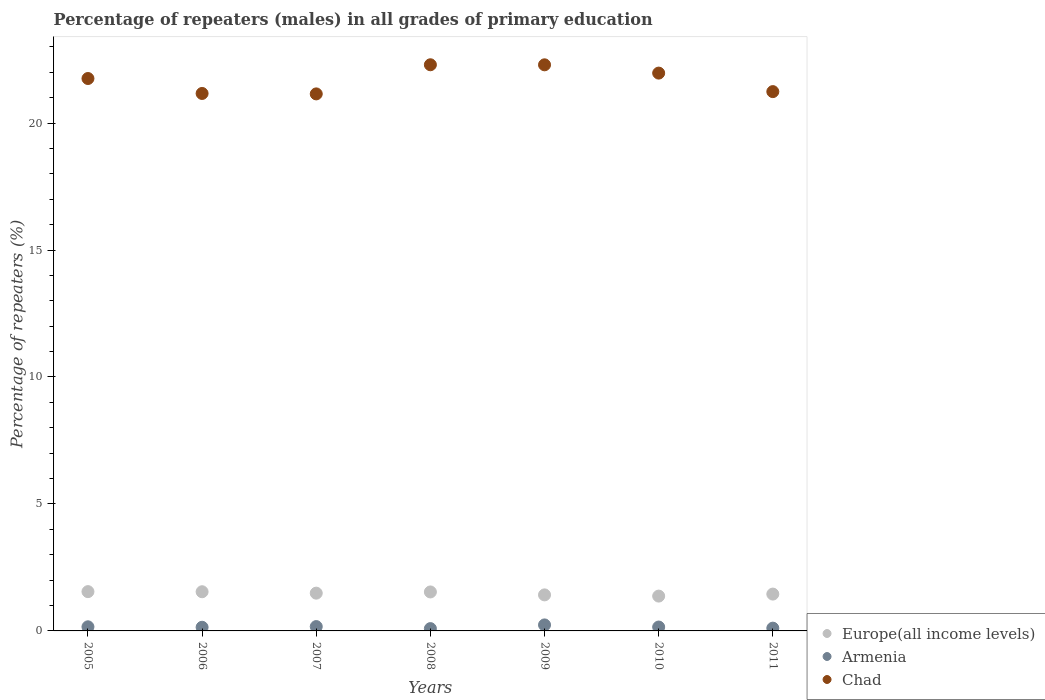Is the number of dotlines equal to the number of legend labels?
Your answer should be very brief. Yes. What is the percentage of repeaters (males) in Chad in 2008?
Keep it short and to the point. 22.29. Across all years, what is the maximum percentage of repeaters (males) in Europe(all income levels)?
Ensure brevity in your answer.  1.55. Across all years, what is the minimum percentage of repeaters (males) in Chad?
Give a very brief answer. 21.15. In which year was the percentage of repeaters (males) in Chad maximum?
Keep it short and to the point. 2008. In which year was the percentage of repeaters (males) in Chad minimum?
Your response must be concise. 2007. What is the total percentage of repeaters (males) in Europe(all income levels) in the graph?
Your answer should be very brief. 10.35. What is the difference between the percentage of repeaters (males) in Europe(all income levels) in 2005 and that in 2006?
Give a very brief answer. 0. What is the difference between the percentage of repeaters (males) in Europe(all income levels) in 2006 and the percentage of repeaters (males) in Chad in 2008?
Make the answer very short. -20.75. What is the average percentage of repeaters (males) in Europe(all income levels) per year?
Your answer should be very brief. 1.48. In the year 2007, what is the difference between the percentage of repeaters (males) in Chad and percentage of repeaters (males) in Armenia?
Your answer should be compact. 20.98. What is the ratio of the percentage of repeaters (males) in Armenia in 2006 to that in 2008?
Provide a short and direct response. 1.58. Is the difference between the percentage of repeaters (males) in Chad in 2007 and 2010 greater than the difference between the percentage of repeaters (males) in Armenia in 2007 and 2010?
Your response must be concise. No. What is the difference between the highest and the second highest percentage of repeaters (males) in Chad?
Offer a terse response. 0. What is the difference between the highest and the lowest percentage of repeaters (males) in Armenia?
Your answer should be compact. 0.15. In how many years, is the percentage of repeaters (males) in Armenia greater than the average percentage of repeaters (males) in Armenia taken over all years?
Offer a terse response. 4. Is the sum of the percentage of repeaters (males) in Armenia in 2005 and 2009 greater than the maximum percentage of repeaters (males) in Chad across all years?
Your answer should be compact. No. How many dotlines are there?
Offer a very short reply. 3. How many years are there in the graph?
Offer a terse response. 7. What is the difference between two consecutive major ticks on the Y-axis?
Ensure brevity in your answer.  5. Where does the legend appear in the graph?
Make the answer very short. Bottom right. What is the title of the graph?
Your answer should be compact. Percentage of repeaters (males) in all grades of primary education. Does "Switzerland" appear as one of the legend labels in the graph?
Keep it short and to the point. No. What is the label or title of the X-axis?
Give a very brief answer. Years. What is the label or title of the Y-axis?
Give a very brief answer. Percentage of repeaters (%). What is the Percentage of repeaters (%) in Europe(all income levels) in 2005?
Provide a succinct answer. 1.55. What is the Percentage of repeaters (%) of Armenia in 2005?
Keep it short and to the point. 0.16. What is the Percentage of repeaters (%) in Chad in 2005?
Your response must be concise. 21.75. What is the Percentage of repeaters (%) of Europe(all income levels) in 2006?
Offer a very short reply. 1.54. What is the Percentage of repeaters (%) of Armenia in 2006?
Provide a short and direct response. 0.14. What is the Percentage of repeaters (%) in Chad in 2006?
Make the answer very short. 21.16. What is the Percentage of repeaters (%) of Europe(all income levels) in 2007?
Your answer should be very brief. 1.49. What is the Percentage of repeaters (%) in Armenia in 2007?
Give a very brief answer. 0.17. What is the Percentage of repeaters (%) in Chad in 2007?
Keep it short and to the point. 21.15. What is the Percentage of repeaters (%) in Europe(all income levels) in 2008?
Keep it short and to the point. 1.53. What is the Percentage of repeaters (%) of Armenia in 2008?
Provide a short and direct response. 0.09. What is the Percentage of repeaters (%) in Chad in 2008?
Ensure brevity in your answer.  22.29. What is the Percentage of repeaters (%) in Europe(all income levels) in 2009?
Provide a succinct answer. 1.42. What is the Percentage of repeaters (%) of Armenia in 2009?
Your response must be concise. 0.24. What is the Percentage of repeaters (%) of Chad in 2009?
Give a very brief answer. 22.29. What is the Percentage of repeaters (%) of Europe(all income levels) in 2010?
Offer a very short reply. 1.37. What is the Percentage of repeaters (%) in Armenia in 2010?
Provide a short and direct response. 0.15. What is the Percentage of repeaters (%) in Chad in 2010?
Give a very brief answer. 21.97. What is the Percentage of repeaters (%) in Europe(all income levels) in 2011?
Ensure brevity in your answer.  1.45. What is the Percentage of repeaters (%) in Armenia in 2011?
Ensure brevity in your answer.  0.11. What is the Percentage of repeaters (%) of Chad in 2011?
Make the answer very short. 21.24. Across all years, what is the maximum Percentage of repeaters (%) in Europe(all income levels)?
Your response must be concise. 1.55. Across all years, what is the maximum Percentage of repeaters (%) of Armenia?
Your response must be concise. 0.24. Across all years, what is the maximum Percentage of repeaters (%) in Chad?
Make the answer very short. 22.29. Across all years, what is the minimum Percentage of repeaters (%) in Europe(all income levels)?
Your response must be concise. 1.37. Across all years, what is the minimum Percentage of repeaters (%) of Armenia?
Keep it short and to the point. 0.09. Across all years, what is the minimum Percentage of repeaters (%) of Chad?
Your answer should be compact. 21.15. What is the total Percentage of repeaters (%) of Europe(all income levels) in the graph?
Offer a very short reply. 10.35. What is the total Percentage of repeaters (%) in Armenia in the graph?
Ensure brevity in your answer.  1.07. What is the total Percentage of repeaters (%) in Chad in the graph?
Ensure brevity in your answer.  151.86. What is the difference between the Percentage of repeaters (%) of Europe(all income levels) in 2005 and that in 2006?
Your answer should be very brief. 0. What is the difference between the Percentage of repeaters (%) of Armenia in 2005 and that in 2006?
Give a very brief answer. 0.02. What is the difference between the Percentage of repeaters (%) in Chad in 2005 and that in 2006?
Offer a terse response. 0.59. What is the difference between the Percentage of repeaters (%) of Europe(all income levels) in 2005 and that in 2007?
Make the answer very short. 0.06. What is the difference between the Percentage of repeaters (%) of Armenia in 2005 and that in 2007?
Provide a succinct answer. -0.01. What is the difference between the Percentage of repeaters (%) of Chad in 2005 and that in 2007?
Provide a short and direct response. 0.61. What is the difference between the Percentage of repeaters (%) in Europe(all income levels) in 2005 and that in 2008?
Make the answer very short. 0.01. What is the difference between the Percentage of repeaters (%) in Armenia in 2005 and that in 2008?
Your answer should be compact. 0.07. What is the difference between the Percentage of repeaters (%) of Chad in 2005 and that in 2008?
Your response must be concise. -0.54. What is the difference between the Percentage of repeaters (%) in Europe(all income levels) in 2005 and that in 2009?
Provide a short and direct response. 0.13. What is the difference between the Percentage of repeaters (%) in Armenia in 2005 and that in 2009?
Offer a terse response. -0.07. What is the difference between the Percentage of repeaters (%) in Chad in 2005 and that in 2009?
Keep it short and to the point. -0.54. What is the difference between the Percentage of repeaters (%) of Europe(all income levels) in 2005 and that in 2010?
Your response must be concise. 0.18. What is the difference between the Percentage of repeaters (%) of Armenia in 2005 and that in 2010?
Make the answer very short. 0.01. What is the difference between the Percentage of repeaters (%) of Chad in 2005 and that in 2010?
Ensure brevity in your answer.  -0.21. What is the difference between the Percentage of repeaters (%) in Europe(all income levels) in 2005 and that in 2011?
Your answer should be very brief. 0.1. What is the difference between the Percentage of repeaters (%) in Armenia in 2005 and that in 2011?
Make the answer very short. 0.05. What is the difference between the Percentage of repeaters (%) in Chad in 2005 and that in 2011?
Your answer should be compact. 0.52. What is the difference between the Percentage of repeaters (%) in Europe(all income levels) in 2006 and that in 2007?
Offer a terse response. 0.06. What is the difference between the Percentage of repeaters (%) of Armenia in 2006 and that in 2007?
Provide a short and direct response. -0.03. What is the difference between the Percentage of repeaters (%) of Chad in 2006 and that in 2007?
Offer a very short reply. 0.02. What is the difference between the Percentage of repeaters (%) in Europe(all income levels) in 2006 and that in 2008?
Provide a short and direct response. 0.01. What is the difference between the Percentage of repeaters (%) of Armenia in 2006 and that in 2008?
Offer a terse response. 0.05. What is the difference between the Percentage of repeaters (%) of Chad in 2006 and that in 2008?
Make the answer very short. -1.13. What is the difference between the Percentage of repeaters (%) of Europe(all income levels) in 2006 and that in 2009?
Give a very brief answer. 0.12. What is the difference between the Percentage of repeaters (%) of Armenia in 2006 and that in 2009?
Your answer should be compact. -0.09. What is the difference between the Percentage of repeaters (%) in Chad in 2006 and that in 2009?
Your response must be concise. -1.13. What is the difference between the Percentage of repeaters (%) of Europe(all income levels) in 2006 and that in 2010?
Give a very brief answer. 0.17. What is the difference between the Percentage of repeaters (%) of Armenia in 2006 and that in 2010?
Offer a terse response. -0.01. What is the difference between the Percentage of repeaters (%) of Chad in 2006 and that in 2010?
Offer a very short reply. -0.8. What is the difference between the Percentage of repeaters (%) of Europe(all income levels) in 2006 and that in 2011?
Your answer should be compact. 0.09. What is the difference between the Percentage of repeaters (%) of Armenia in 2006 and that in 2011?
Give a very brief answer. 0.03. What is the difference between the Percentage of repeaters (%) in Chad in 2006 and that in 2011?
Provide a succinct answer. -0.07. What is the difference between the Percentage of repeaters (%) in Europe(all income levels) in 2007 and that in 2008?
Offer a terse response. -0.05. What is the difference between the Percentage of repeaters (%) of Armenia in 2007 and that in 2008?
Your answer should be very brief. 0.08. What is the difference between the Percentage of repeaters (%) in Chad in 2007 and that in 2008?
Your answer should be very brief. -1.15. What is the difference between the Percentage of repeaters (%) in Europe(all income levels) in 2007 and that in 2009?
Provide a succinct answer. 0.07. What is the difference between the Percentage of repeaters (%) of Armenia in 2007 and that in 2009?
Your response must be concise. -0.07. What is the difference between the Percentage of repeaters (%) in Chad in 2007 and that in 2009?
Offer a very short reply. -1.15. What is the difference between the Percentage of repeaters (%) of Europe(all income levels) in 2007 and that in 2010?
Your answer should be very brief. 0.12. What is the difference between the Percentage of repeaters (%) of Armenia in 2007 and that in 2010?
Offer a terse response. 0.02. What is the difference between the Percentage of repeaters (%) of Chad in 2007 and that in 2010?
Provide a succinct answer. -0.82. What is the difference between the Percentage of repeaters (%) of Europe(all income levels) in 2007 and that in 2011?
Make the answer very short. 0.04. What is the difference between the Percentage of repeaters (%) in Armenia in 2007 and that in 2011?
Your answer should be compact. 0.06. What is the difference between the Percentage of repeaters (%) in Chad in 2007 and that in 2011?
Your response must be concise. -0.09. What is the difference between the Percentage of repeaters (%) in Europe(all income levels) in 2008 and that in 2009?
Make the answer very short. 0.12. What is the difference between the Percentage of repeaters (%) of Armenia in 2008 and that in 2009?
Your response must be concise. -0.15. What is the difference between the Percentage of repeaters (%) of Chad in 2008 and that in 2009?
Give a very brief answer. 0. What is the difference between the Percentage of repeaters (%) in Europe(all income levels) in 2008 and that in 2010?
Keep it short and to the point. 0.16. What is the difference between the Percentage of repeaters (%) of Armenia in 2008 and that in 2010?
Give a very brief answer. -0.06. What is the difference between the Percentage of repeaters (%) in Chad in 2008 and that in 2010?
Keep it short and to the point. 0.33. What is the difference between the Percentage of repeaters (%) of Europe(all income levels) in 2008 and that in 2011?
Make the answer very short. 0.08. What is the difference between the Percentage of repeaters (%) in Armenia in 2008 and that in 2011?
Offer a terse response. -0.02. What is the difference between the Percentage of repeaters (%) of Chad in 2008 and that in 2011?
Your answer should be compact. 1.06. What is the difference between the Percentage of repeaters (%) of Europe(all income levels) in 2009 and that in 2010?
Provide a short and direct response. 0.05. What is the difference between the Percentage of repeaters (%) of Armenia in 2009 and that in 2010?
Your answer should be very brief. 0.08. What is the difference between the Percentage of repeaters (%) of Chad in 2009 and that in 2010?
Your response must be concise. 0.33. What is the difference between the Percentage of repeaters (%) of Europe(all income levels) in 2009 and that in 2011?
Make the answer very short. -0.03. What is the difference between the Percentage of repeaters (%) in Armenia in 2009 and that in 2011?
Provide a short and direct response. 0.13. What is the difference between the Percentage of repeaters (%) in Chad in 2009 and that in 2011?
Offer a very short reply. 1.06. What is the difference between the Percentage of repeaters (%) in Europe(all income levels) in 2010 and that in 2011?
Offer a very short reply. -0.08. What is the difference between the Percentage of repeaters (%) of Armenia in 2010 and that in 2011?
Give a very brief answer. 0.04. What is the difference between the Percentage of repeaters (%) of Chad in 2010 and that in 2011?
Make the answer very short. 0.73. What is the difference between the Percentage of repeaters (%) in Europe(all income levels) in 2005 and the Percentage of repeaters (%) in Armenia in 2006?
Provide a succinct answer. 1.4. What is the difference between the Percentage of repeaters (%) in Europe(all income levels) in 2005 and the Percentage of repeaters (%) in Chad in 2006?
Your answer should be compact. -19.62. What is the difference between the Percentage of repeaters (%) in Armenia in 2005 and the Percentage of repeaters (%) in Chad in 2006?
Provide a succinct answer. -21. What is the difference between the Percentage of repeaters (%) of Europe(all income levels) in 2005 and the Percentage of repeaters (%) of Armenia in 2007?
Your answer should be very brief. 1.38. What is the difference between the Percentage of repeaters (%) in Europe(all income levels) in 2005 and the Percentage of repeaters (%) in Chad in 2007?
Ensure brevity in your answer.  -19.6. What is the difference between the Percentage of repeaters (%) in Armenia in 2005 and the Percentage of repeaters (%) in Chad in 2007?
Your answer should be very brief. -20.99. What is the difference between the Percentage of repeaters (%) in Europe(all income levels) in 2005 and the Percentage of repeaters (%) in Armenia in 2008?
Offer a very short reply. 1.46. What is the difference between the Percentage of repeaters (%) in Europe(all income levels) in 2005 and the Percentage of repeaters (%) in Chad in 2008?
Your response must be concise. -20.75. What is the difference between the Percentage of repeaters (%) of Armenia in 2005 and the Percentage of repeaters (%) of Chad in 2008?
Give a very brief answer. -22.13. What is the difference between the Percentage of repeaters (%) of Europe(all income levels) in 2005 and the Percentage of repeaters (%) of Armenia in 2009?
Offer a terse response. 1.31. What is the difference between the Percentage of repeaters (%) of Europe(all income levels) in 2005 and the Percentage of repeaters (%) of Chad in 2009?
Provide a succinct answer. -20.75. What is the difference between the Percentage of repeaters (%) in Armenia in 2005 and the Percentage of repeaters (%) in Chad in 2009?
Your response must be concise. -22.13. What is the difference between the Percentage of repeaters (%) in Europe(all income levels) in 2005 and the Percentage of repeaters (%) in Armenia in 2010?
Your answer should be compact. 1.39. What is the difference between the Percentage of repeaters (%) of Europe(all income levels) in 2005 and the Percentage of repeaters (%) of Chad in 2010?
Offer a terse response. -20.42. What is the difference between the Percentage of repeaters (%) of Armenia in 2005 and the Percentage of repeaters (%) of Chad in 2010?
Make the answer very short. -21.8. What is the difference between the Percentage of repeaters (%) of Europe(all income levels) in 2005 and the Percentage of repeaters (%) of Armenia in 2011?
Ensure brevity in your answer.  1.44. What is the difference between the Percentage of repeaters (%) of Europe(all income levels) in 2005 and the Percentage of repeaters (%) of Chad in 2011?
Ensure brevity in your answer.  -19.69. What is the difference between the Percentage of repeaters (%) of Armenia in 2005 and the Percentage of repeaters (%) of Chad in 2011?
Offer a very short reply. -21.08. What is the difference between the Percentage of repeaters (%) in Europe(all income levels) in 2006 and the Percentage of repeaters (%) in Armenia in 2007?
Keep it short and to the point. 1.37. What is the difference between the Percentage of repeaters (%) of Europe(all income levels) in 2006 and the Percentage of repeaters (%) of Chad in 2007?
Keep it short and to the point. -19.6. What is the difference between the Percentage of repeaters (%) of Armenia in 2006 and the Percentage of repeaters (%) of Chad in 2007?
Ensure brevity in your answer.  -21. What is the difference between the Percentage of repeaters (%) in Europe(all income levels) in 2006 and the Percentage of repeaters (%) in Armenia in 2008?
Keep it short and to the point. 1.45. What is the difference between the Percentage of repeaters (%) in Europe(all income levels) in 2006 and the Percentage of repeaters (%) in Chad in 2008?
Ensure brevity in your answer.  -20.75. What is the difference between the Percentage of repeaters (%) in Armenia in 2006 and the Percentage of repeaters (%) in Chad in 2008?
Your answer should be compact. -22.15. What is the difference between the Percentage of repeaters (%) in Europe(all income levels) in 2006 and the Percentage of repeaters (%) in Armenia in 2009?
Your answer should be compact. 1.31. What is the difference between the Percentage of repeaters (%) of Europe(all income levels) in 2006 and the Percentage of repeaters (%) of Chad in 2009?
Give a very brief answer. -20.75. What is the difference between the Percentage of repeaters (%) in Armenia in 2006 and the Percentage of repeaters (%) in Chad in 2009?
Your answer should be compact. -22.15. What is the difference between the Percentage of repeaters (%) of Europe(all income levels) in 2006 and the Percentage of repeaters (%) of Armenia in 2010?
Your response must be concise. 1.39. What is the difference between the Percentage of repeaters (%) of Europe(all income levels) in 2006 and the Percentage of repeaters (%) of Chad in 2010?
Offer a very short reply. -20.42. What is the difference between the Percentage of repeaters (%) in Armenia in 2006 and the Percentage of repeaters (%) in Chad in 2010?
Ensure brevity in your answer.  -21.82. What is the difference between the Percentage of repeaters (%) in Europe(all income levels) in 2006 and the Percentage of repeaters (%) in Armenia in 2011?
Your answer should be compact. 1.43. What is the difference between the Percentage of repeaters (%) in Europe(all income levels) in 2006 and the Percentage of repeaters (%) in Chad in 2011?
Provide a succinct answer. -19.69. What is the difference between the Percentage of repeaters (%) in Armenia in 2006 and the Percentage of repeaters (%) in Chad in 2011?
Make the answer very short. -21.09. What is the difference between the Percentage of repeaters (%) in Europe(all income levels) in 2007 and the Percentage of repeaters (%) in Armenia in 2008?
Your response must be concise. 1.4. What is the difference between the Percentage of repeaters (%) of Europe(all income levels) in 2007 and the Percentage of repeaters (%) of Chad in 2008?
Your answer should be compact. -20.81. What is the difference between the Percentage of repeaters (%) of Armenia in 2007 and the Percentage of repeaters (%) of Chad in 2008?
Offer a very short reply. -22.12. What is the difference between the Percentage of repeaters (%) in Europe(all income levels) in 2007 and the Percentage of repeaters (%) in Armenia in 2009?
Your answer should be very brief. 1.25. What is the difference between the Percentage of repeaters (%) in Europe(all income levels) in 2007 and the Percentage of repeaters (%) in Chad in 2009?
Provide a short and direct response. -20.81. What is the difference between the Percentage of repeaters (%) in Armenia in 2007 and the Percentage of repeaters (%) in Chad in 2009?
Offer a very short reply. -22.12. What is the difference between the Percentage of repeaters (%) in Europe(all income levels) in 2007 and the Percentage of repeaters (%) in Armenia in 2010?
Your answer should be very brief. 1.33. What is the difference between the Percentage of repeaters (%) in Europe(all income levels) in 2007 and the Percentage of repeaters (%) in Chad in 2010?
Offer a very short reply. -20.48. What is the difference between the Percentage of repeaters (%) of Armenia in 2007 and the Percentage of repeaters (%) of Chad in 2010?
Offer a terse response. -21.8. What is the difference between the Percentage of repeaters (%) of Europe(all income levels) in 2007 and the Percentage of repeaters (%) of Armenia in 2011?
Offer a terse response. 1.38. What is the difference between the Percentage of repeaters (%) of Europe(all income levels) in 2007 and the Percentage of repeaters (%) of Chad in 2011?
Give a very brief answer. -19.75. What is the difference between the Percentage of repeaters (%) of Armenia in 2007 and the Percentage of repeaters (%) of Chad in 2011?
Ensure brevity in your answer.  -21.07. What is the difference between the Percentage of repeaters (%) in Europe(all income levels) in 2008 and the Percentage of repeaters (%) in Armenia in 2009?
Keep it short and to the point. 1.3. What is the difference between the Percentage of repeaters (%) in Europe(all income levels) in 2008 and the Percentage of repeaters (%) in Chad in 2009?
Offer a terse response. -20.76. What is the difference between the Percentage of repeaters (%) of Armenia in 2008 and the Percentage of repeaters (%) of Chad in 2009?
Keep it short and to the point. -22.2. What is the difference between the Percentage of repeaters (%) in Europe(all income levels) in 2008 and the Percentage of repeaters (%) in Armenia in 2010?
Ensure brevity in your answer.  1.38. What is the difference between the Percentage of repeaters (%) of Europe(all income levels) in 2008 and the Percentage of repeaters (%) of Chad in 2010?
Provide a succinct answer. -20.43. What is the difference between the Percentage of repeaters (%) in Armenia in 2008 and the Percentage of repeaters (%) in Chad in 2010?
Provide a succinct answer. -21.88. What is the difference between the Percentage of repeaters (%) of Europe(all income levels) in 2008 and the Percentage of repeaters (%) of Armenia in 2011?
Provide a short and direct response. 1.43. What is the difference between the Percentage of repeaters (%) of Europe(all income levels) in 2008 and the Percentage of repeaters (%) of Chad in 2011?
Make the answer very short. -19.7. What is the difference between the Percentage of repeaters (%) of Armenia in 2008 and the Percentage of repeaters (%) of Chad in 2011?
Ensure brevity in your answer.  -21.15. What is the difference between the Percentage of repeaters (%) in Europe(all income levels) in 2009 and the Percentage of repeaters (%) in Armenia in 2010?
Keep it short and to the point. 1.27. What is the difference between the Percentage of repeaters (%) of Europe(all income levels) in 2009 and the Percentage of repeaters (%) of Chad in 2010?
Your answer should be compact. -20.55. What is the difference between the Percentage of repeaters (%) of Armenia in 2009 and the Percentage of repeaters (%) of Chad in 2010?
Provide a short and direct response. -21.73. What is the difference between the Percentage of repeaters (%) in Europe(all income levels) in 2009 and the Percentage of repeaters (%) in Armenia in 2011?
Offer a very short reply. 1.31. What is the difference between the Percentage of repeaters (%) in Europe(all income levels) in 2009 and the Percentage of repeaters (%) in Chad in 2011?
Your answer should be compact. -19.82. What is the difference between the Percentage of repeaters (%) of Armenia in 2009 and the Percentage of repeaters (%) of Chad in 2011?
Provide a succinct answer. -21. What is the difference between the Percentage of repeaters (%) of Europe(all income levels) in 2010 and the Percentage of repeaters (%) of Armenia in 2011?
Offer a terse response. 1.26. What is the difference between the Percentage of repeaters (%) in Europe(all income levels) in 2010 and the Percentage of repeaters (%) in Chad in 2011?
Provide a succinct answer. -19.87. What is the difference between the Percentage of repeaters (%) of Armenia in 2010 and the Percentage of repeaters (%) of Chad in 2011?
Offer a very short reply. -21.08. What is the average Percentage of repeaters (%) in Europe(all income levels) per year?
Offer a terse response. 1.48. What is the average Percentage of repeaters (%) of Armenia per year?
Ensure brevity in your answer.  0.15. What is the average Percentage of repeaters (%) of Chad per year?
Offer a very short reply. 21.69. In the year 2005, what is the difference between the Percentage of repeaters (%) of Europe(all income levels) and Percentage of repeaters (%) of Armenia?
Offer a very short reply. 1.39. In the year 2005, what is the difference between the Percentage of repeaters (%) of Europe(all income levels) and Percentage of repeaters (%) of Chad?
Give a very brief answer. -20.21. In the year 2005, what is the difference between the Percentage of repeaters (%) of Armenia and Percentage of repeaters (%) of Chad?
Your answer should be very brief. -21.59. In the year 2006, what is the difference between the Percentage of repeaters (%) of Europe(all income levels) and Percentage of repeaters (%) of Armenia?
Your answer should be very brief. 1.4. In the year 2006, what is the difference between the Percentage of repeaters (%) of Europe(all income levels) and Percentage of repeaters (%) of Chad?
Provide a short and direct response. -19.62. In the year 2006, what is the difference between the Percentage of repeaters (%) of Armenia and Percentage of repeaters (%) of Chad?
Provide a short and direct response. -21.02. In the year 2007, what is the difference between the Percentage of repeaters (%) of Europe(all income levels) and Percentage of repeaters (%) of Armenia?
Offer a terse response. 1.32. In the year 2007, what is the difference between the Percentage of repeaters (%) of Europe(all income levels) and Percentage of repeaters (%) of Chad?
Offer a terse response. -19.66. In the year 2007, what is the difference between the Percentage of repeaters (%) of Armenia and Percentage of repeaters (%) of Chad?
Your answer should be very brief. -20.98. In the year 2008, what is the difference between the Percentage of repeaters (%) in Europe(all income levels) and Percentage of repeaters (%) in Armenia?
Offer a terse response. 1.44. In the year 2008, what is the difference between the Percentage of repeaters (%) in Europe(all income levels) and Percentage of repeaters (%) in Chad?
Offer a very short reply. -20.76. In the year 2008, what is the difference between the Percentage of repeaters (%) of Armenia and Percentage of repeaters (%) of Chad?
Offer a very short reply. -22.2. In the year 2009, what is the difference between the Percentage of repeaters (%) of Europe(all income levels) and Percentage of repeaters (%) of Armenia?
Your answer should be compact. 1.18. In the year 2009, what is the difference between the Percentage of repeaters (%) in Europe(all income levels) and Percentage of repeaters (%) in Chad?
Ensure brevity in your answer.  -20.87. In the year 2009, what is the difference between the Percentage of repeaters (%) in Armenia and Percentage of repeaters (%) in Chad?
Give a very brief answer. -22.06. In the year 2010, what is the difference between the Percentage of repeaters (%) in Europe(all income levels) and Percentage of repeaters (%) in Armenia?
Provide a short and direct response. 1.22. In the year 2010, what is the difference between the Percentage of repeaters (%) in Europe(all income levels) and Percentage of repeaters (%) in Chad?
Your answer should be very brief. -20.59. In the year 2010, what is the difference between the Percentage of repeaters (%) in Armenia and Percentage of repeaters (%) in Chad?
Your answer should be very brief. -21.81. In the year 2011, what is the difference between the Percentage of repeaters (%) of Europe(all income levels) and Percentage of repeaters (%) of Armenia?
Your response must be concise. 1.34. In the year 2011, what is the difference between the Percentage of repeaters (%) in Europe(all income levels) and Percentage of repeaters (%) in Chad?
Provide a succinct answer. -19.79. In the year 2011, what is the difference between the Percentage of repeaters (%) of Armenia and Percentage of repeaters (%) of Chad?
Your answer should be very brief. -21.13. What is the ratio of the Percentage of repeaters (%) in Europe(all income levels) in 2005 to that in 2006?
Your answer should be compact. 1. What is the ratio of the Percentage of repeaters (%) in Armenia in 2005 to that in 2006?
Your answer should be very brief. 1.13. What is the ratio of the Percentage of repeaters (%) in Chad in 2005 to that in 2006?
Keep it short and to the point. 1.03. What is the ratio of the Percentage of repeaters (%) in Europe(all income levels) in 2005 to that in 2007?
Offer a terse response. 1.04. What is the ratio of the Percentage of repeaters (%) of Armenia in 2005 to that in 2007?
Ensure brevity in your answer.  0.95. What is the ratio of the Percentage of repeaters (%) of Chad in 2005 to that in 2007?
Your response must be concise. 1.03. What is the ratio of the Percentage of repeaters (%) in Armenia in 2005 to that in 2008?
Ensure brevity in your answer.  1.78. What is the ratio of the Percentage of repeaters (%) of Chad in 2005 to that in 2008?
Keep it short and to the point. 0.98. What is the ratio of the Percentage of repeaters (%) in Europe(all income levels) in 2005 to that in 2009?
Your answer should be very brief. 1.09. What is the ratio of the Percentage of repeaters (%) in Armenia in 2005 to that in 2009?
Your response must be concise. 0.68. What is the ratio of the Percentage of repeaters (%) of Chad in 2005 to that in 2009?
Your response must be concise. 0.98. What is the ratio of the Percentage of repeaters (%) of Europe(all income levels) in 2005 to that in 2010?
Offer a very short reply. 1.13. What is the ratio of the Percentage of repeaters (%) in Armenia in 2005 to that in 2010?
Your answer should be compact. 1.06. What is the ratio of the Percentage of repeaters (%) in Chad in 2005 to that in 2010?
Keep it short and to the point. 0.99. What is the ratio of the Percentage of repeaters (%) in Europe(all income levels) in 2005 to that in 2011?
Provide a succinct answer. 1.07. What is the ratio of the Percentage of repeaters (%) of Armenia in 2005 to that in 2011?
Offer a very short reply. 1.48. What is the ratio of the Percentage of repeaters (%) in Chad in 2005 to that in 2011?
Offer a terse response. 1.02. What is the ratio of the Percentage of repeaters (%) of Europe(all income levels) in 2006 to that in 2007?
Your response must be concise. 1.04. What is the ratio of the Percentage of repeaters (%) of Armenia in 2006 to that in 2007?
Offer a very short reply. 0.84. What is the ratio of the Percentage of repeaters (%) in Chad in 2006 to that in 2007?
Your response must be concise. 1. What is the ratio of the Percentage of repeaters (%) of Europe(all income levels) in 2006 to that in 2008?
Your answer should be compact. 1.01. What is the ratio of the Percentage of repeaters (%) of Armenia in 2006 to that in 2008?
Provide a short and direct response. 1.58. What is the ratio of the Percentage of repeaters (%) of Chad in 2006 to that in 2008?
Offer a terse response. 0.95. What is the ratio of the Percentage of repeaters (%) in Europe(all income levels) in 2006 to that in 2009?
Offer a very short reply. 1.09. What is the ratio of the Percentage of repeaters (%) in Armenia in 2006 to that in 2009?
Your answer should be compact. 0.61. What is the ratio of the Percentage of repeaters (%) in Chad in 2006 to that in 2009?
Provide a short and direct response. 0.95. What is the ratio of the Percentage of repeaters (%) of Europe(all income levels) in 2006 to that in 2010?
Make the answer very short. 1.12. What is the ratio of the Percentage of repeaters (%) of Armenia in 2006 to that in 2010?
Provide a succinct answer. 0.94. What is the ratio of the Percentage of repeaters (%) of Chad in 2006 to that in 2010?
Offer a very short reply. 0.96. What is the ratio of the Percentage of repeaters (%) in Europe(all income levels) in 2006 to that in 2011?
Ensure brevity in your answer.  1.06. What is the ratio of the Percentage of repeaters (%) of Armenia in 2006 to that in 2011?
Your response must be concise. 1.31. What is the ratio of the Percentage of repeaters (%) in Chad in 2006 to that in 2011?
Your response must be concise. 1. What is the ratio of the Percentage of repeaters (%) of Europe(all income levels) in 2007 to that in 2008?
Ensure brevity in your answer.  0.97. What is the ratio of the Percentage of repeaters (%) of Armenia in 2007 to that in 2008?
Your answer should be very brief. 1.88. What is the ratio of the Percentage of repeaters (%) of Chad in 2007 to that in 2008?
Provide a succinct answer. 0.95. What is the ratio of the Percentage of repeaters (%) of Europe(all income levels) in 2007 to that in 2009?
Your response must be concise. 1.05. What is the ratio of the Percentage of repeaters (%) of Armenia in 2007 to that in 2009?
Offer a very short reply. 0.72. What is the ratio of the Percentage of repeaters (%) in Chad in 2007 to that in 2009?
Provide a short and direct response. 0.95. What is the ratio of the Percentage of repeaters (%) in Europe(all income levels) in 2007 to that in 2010?
Your answer should be compact. 1.08. What is the ratio of the Percentage of repeaters (%) of Armenia in 2007 to that in 2010?
Give a very brief answer. 1.11. What is the ratio of the Percentage of repeaters (%) in Chad in 2007 to that in 2010?
Give a very brief answer. 0.96. What is the ratio of the Percentage of repeaters (%) of Europe(all income levels) in 2007 to that in 2011?
Keep it short and to the point. 1.03. What is the ratio of the Percentage of repeaters (%) of Armenia in 2007 to that in 2011?
Keep it short and to the point. 1.56. What is the ratio of the Percentage of repeaters (%) of Europe(all income levels) in 2008 to that in 2009?
Keep it short and to the point. 1.08. What is the ratio of the Percentage of repeaters (%) of Armenia in 2008 to that in 2009?
Provide a succinct answer. 0.38. What is the ratio of the Percentage of repeaters (%) in Europe(all income levels) in 2008 to that in 2010?
Your answer should be very brief. 1.12. What is the ratio of the Percentage of repeaters (%) in Armenia in 2008 to that in 2010?
Your answer should be compact. 0.59. What is the ratio of the Percentage of repeaters (%) in Chad in 2008 to that in 2010?
Provide a short and direct response. 1.01. What is the ratio of the Percentage of repeaters (%) in Europe(all income levels) in 2008 to that in 2011?
Your answer should be compact. 1.06. What is the ratio of the Percentage of repeaters (%) of Armenia in 2008 to that in 2011?
Make the answer very short. 0.83. What is the ratio of the Percentage of repeaters (%) in Chad in 2008 to that in 2011?
Offer a very short reply. 1.05. What is the ratio of the Percentage of repeaters (%) in Europe(all income levels) in 2009 to that in 2010?
Offer a terse response. 1.03. What is the ratio of the Percentage of repeaters (%) in Armenia in 2009 to that in 2010?
Ensure brevity in your answer.  1.54. What is the ratio of the Percentage of repeaters (%) of Chad in 2009 to that in 2010?
Offer a very short reply. 1.01. What is the ratio of the Percentage of repeaters (%) of Europe(all income levels) in 2009 to that in 2011?
Make the answer very short. 0.98. What is the ratio of the Percentage of repeaters (%) of Armenia in 2009 to that in 2011?
Offer a terse response. 2.16. What is the ratio of the Percentage of repeaters (%) of Chad in 2009 to that in 2011?
Offer a terse response. 1.05. What is the ratio of the Percentage of repeaters (%) of Europe(all income levels) in 2010 to that in 2011?
Offer a very short reply. 0.95. What is the ratio of the Percentage of repeaters (%) in Armenia in 2010 to that in 2011?
Your answer should be very brief. 1.4. What is the ratio of the Percentage of repeaters (%) of Chad in 2010 to that in 2011?
Your response must be concise. 1.03. What is the difference between the highest and the second highest Percentage of repeaters (%) of Europe(all income levels)?
Offer a very short reply. 0. What is the difference between the highest and the second highest Percentage of repeaters (%) of Armenia?
Ensure brevity in your answer.  0.07. What is the difference between the highest and the second highest Percentage of repeaters (%) in Chad?
Offer a very short reply. 0. What is the difference between the highest and the lowest Percentage of repeaters (%) of Europe(all income levels)?
Offer a terse response. 0.18. What is the difference between the highest and the lowest Percentage of repeaters (%) in Armenia?
Make the answer very short. 0.15. What is the difference between the highest and the lowest Percentage of repeaters (%) of Chad?
Provide a succinct answer. 1.15. 